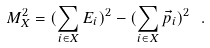Convert formula to latex. <formula><loc_0><loc_0><loc_500><loc_500>M _ { X } ^ { 2 } = ( \sum _ { i \in X } E _ { i } ) ^ { 2 } - ( \sum _ { i \in X } \vec { p } _ { i } ) ^ { 2 } \ .</formula> 